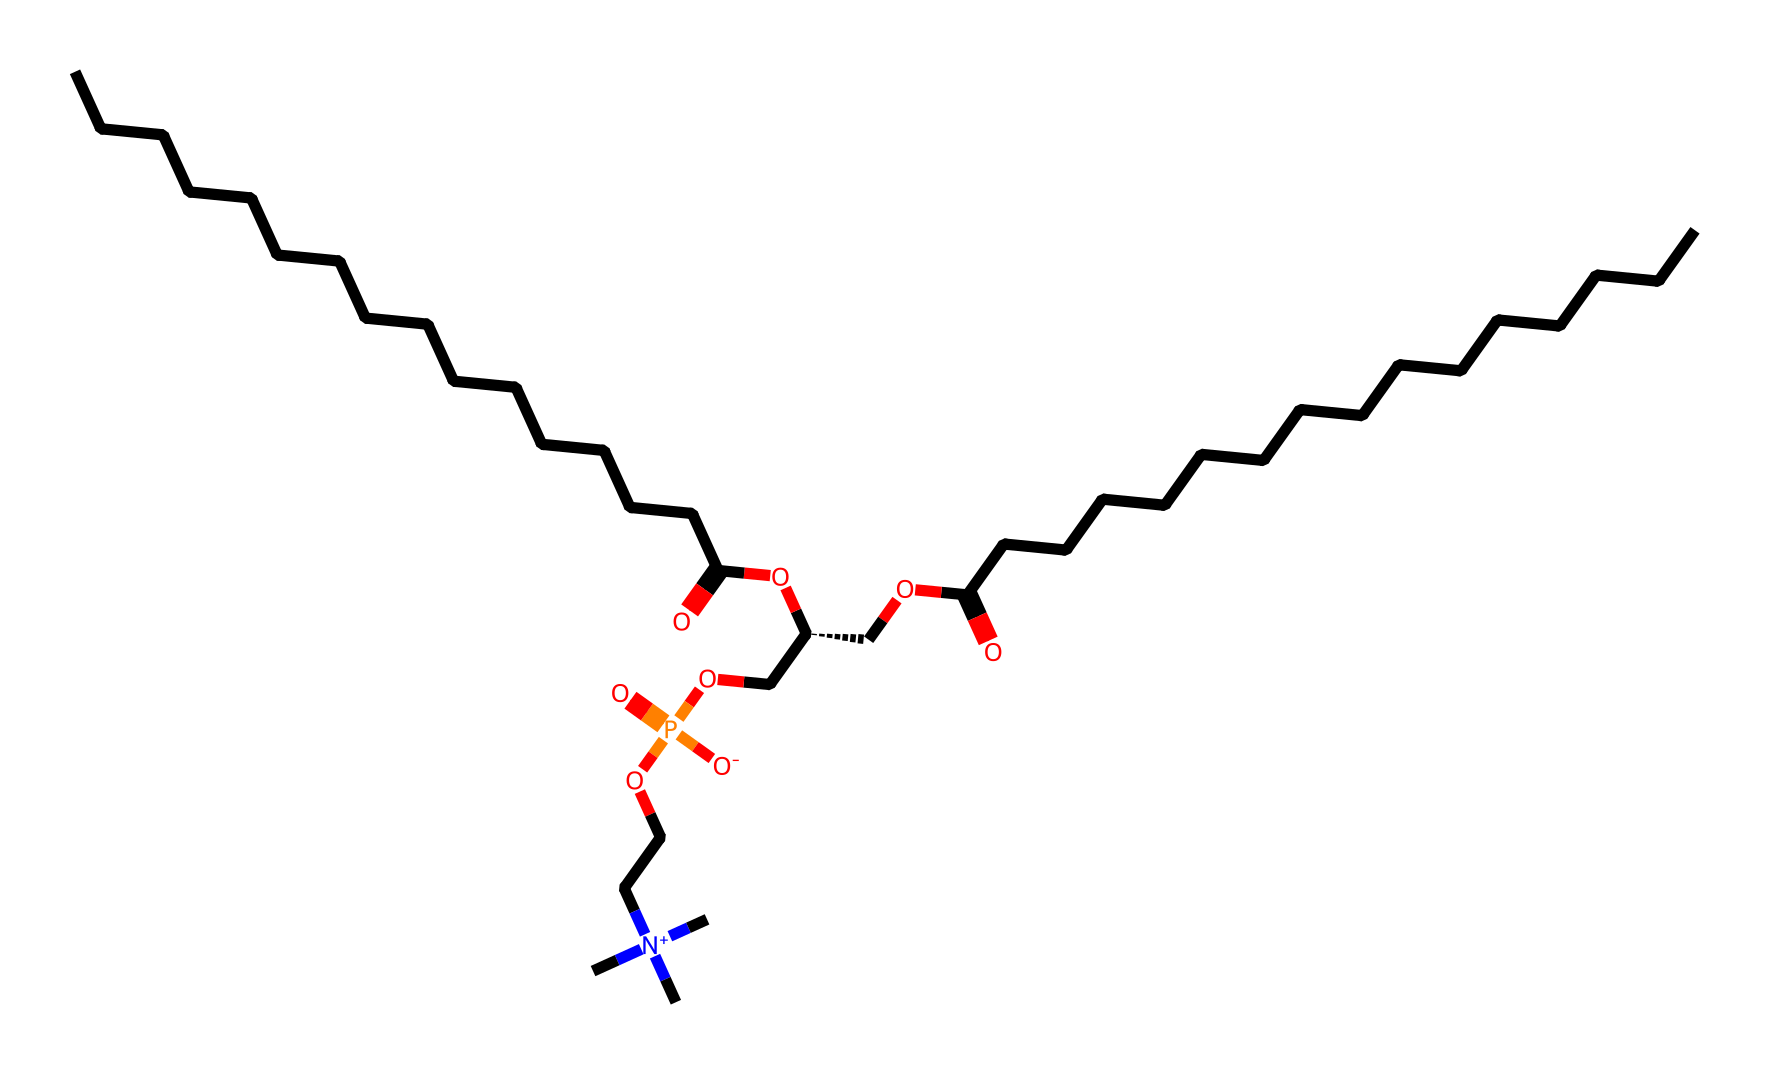What is the main functional group present in phosphatidylcholine? The chemical structure includes a phosphate group connected to the glycerol backbone; this makes the phosphate the main functional group.
Answer: phosphate How many carbon atoms are present in the longest chain of phosphatidylcholine? By inspecting the structure, there are 16 carbon atoms in one fatty acid chain and 17 in the other, making a total of 33.
Answer: 33 What charge does the nitrogen atom in phosphatidylcholine carry? The nitrogen atom is part of a quaternary ammonium group, which has a positive charge due to the four substituents attached.
Answer: positive How many ester bonds are present in phosphatidylcholine? The structure has two ester bonds formed between the fatty acid chains and the glycerol backbone, as indicated by the presence of two –O–C=O groups.
Answer: 2 What is the role of phosphatidylcholine in biological systems? Phosphatidylcholine is a critical component of cell membranes, facilitating structure and membrane fluidity due to its amphiphilic nature.
Answer: cell membranes 